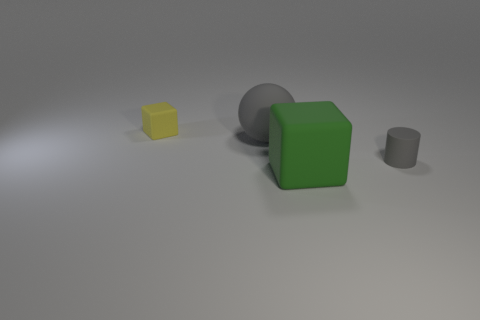What material is the gray object on the left side of the tiny matte cylinder?
Your response must be concise. Rubber. Are there the same number of green matte cubes on the left side of the big matte cube and large blue spheres?
Give a very brief answer. Yes. Do the tiny yellow thing and the large gray matte object have the same shape?
Give a very brief answer. No. Is there any other thing that is the same color as the matte cylinder?
Provide a succinct answer. Yes. What is the shape of the object that is on the right side of the ball and on the left side of the tiny matte cylinder?
Offer a very short reply. Cube. Is the number of large things that are behind the gray sphere the same as the number of cylinders that are on the left side of the small matte block?
Your answer should be very brief. Yes. How many cylinders are either tiny metal objects or gray matte things?
Your response must be concise. 1. How many cyan things are the same material as the sphere?
Ensure brevity in your answer.  0. What shape is the object that is the same color as the large matte ball?
Offer a terse response. Cylinder. What is the object that is both left of the big green rubber block and in front of the small yellow matte cube made of?
Provide a succinct answer. Rubber. 